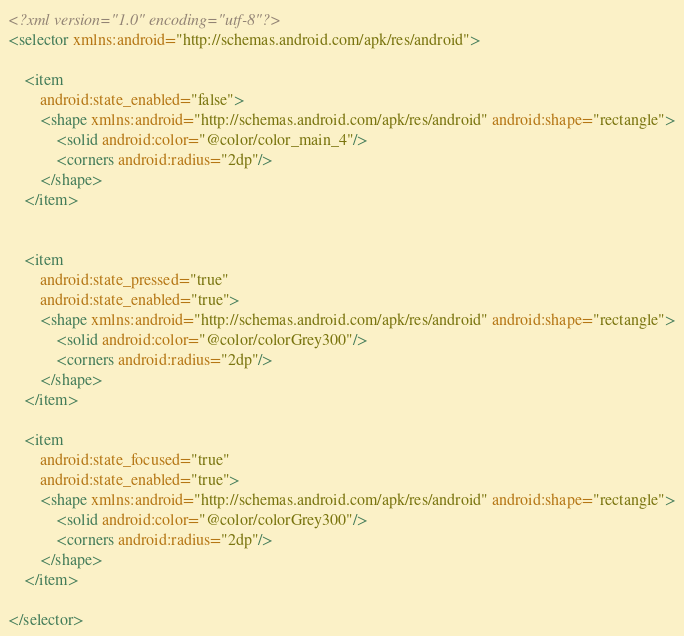Convert code to text. <code><loc_0><loc_0><loc_500><loc_500><_XML_><?xml version="1.0" encoding="utf-8"?>
<selector xmlns:android="http://schemas.android.com/apk/res/android">

    <item
        android:state_enabled="false">
        <shape xmlns:android="http://schemas.android.com/apk/res/android" android:shape="rectangle">
            <solid android:color="@color/color_main_4"/>
            <corners android:radius="2dp"/>
        </shape>
    </item>


    <item
        android:state_pressed="true"
        android:state_enabled="true">
        <shape xmlns:android="http://schemas.android.com/apk/res/android" android:shape="rectangle">
            <solid android:color="@color/colorGrey300"/>
            <corners android:radius="2dp"/>
        </shape>
    </item>

    <item
        android:state_focused="true"
        android:state_enabled="true">
        <shape xmlns:android="http://schemas.android.com/apk/res/android" android:shape="rectangle">
            <solid android:color="@color/colorGrey300"/>
            <corners android:radius="2dp"/>
        </shape>
    </item>

</selector></code> 